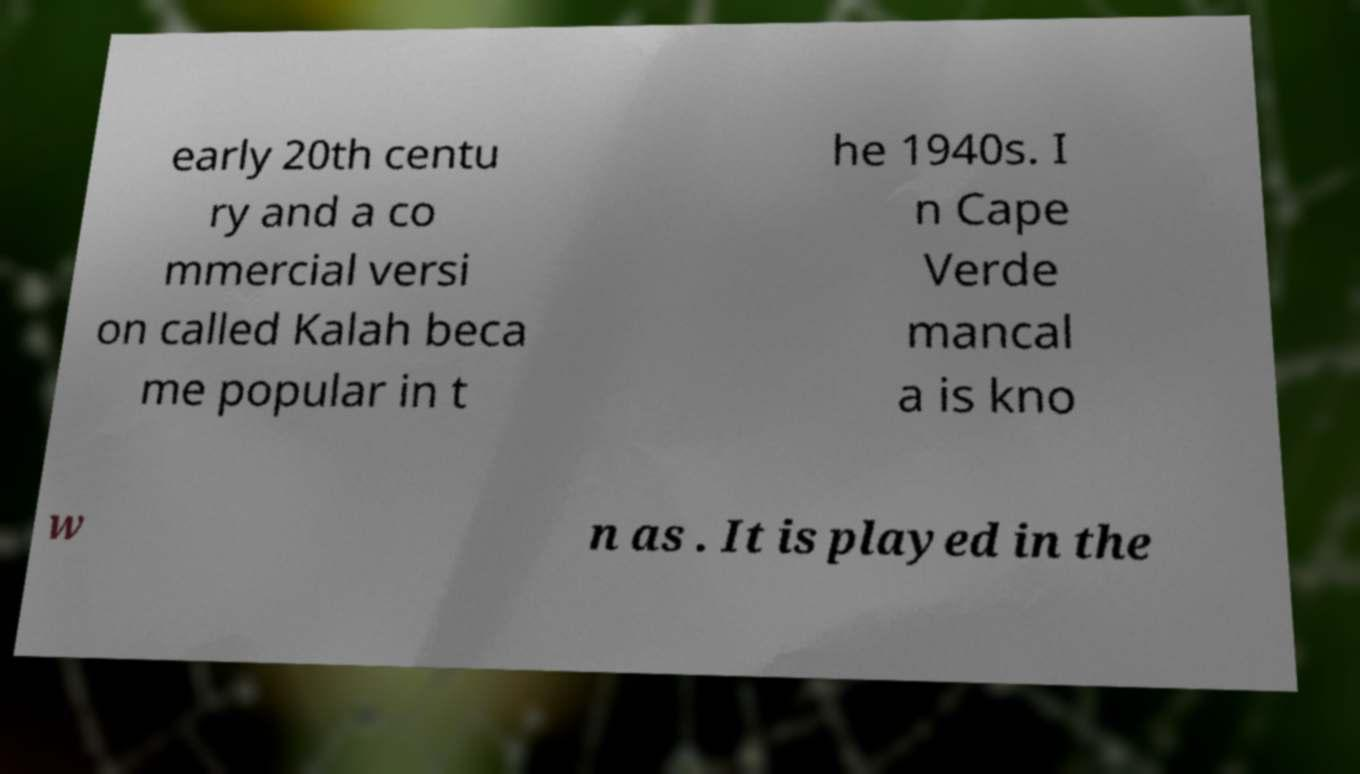Can you accurately transcribe the text from the provided image for me? early 20th centu ry and a co mmercial versi on called Kalah beca me popular in t he 1940s. I n Cape Verde mancal a is kno w n as . It is played in the 